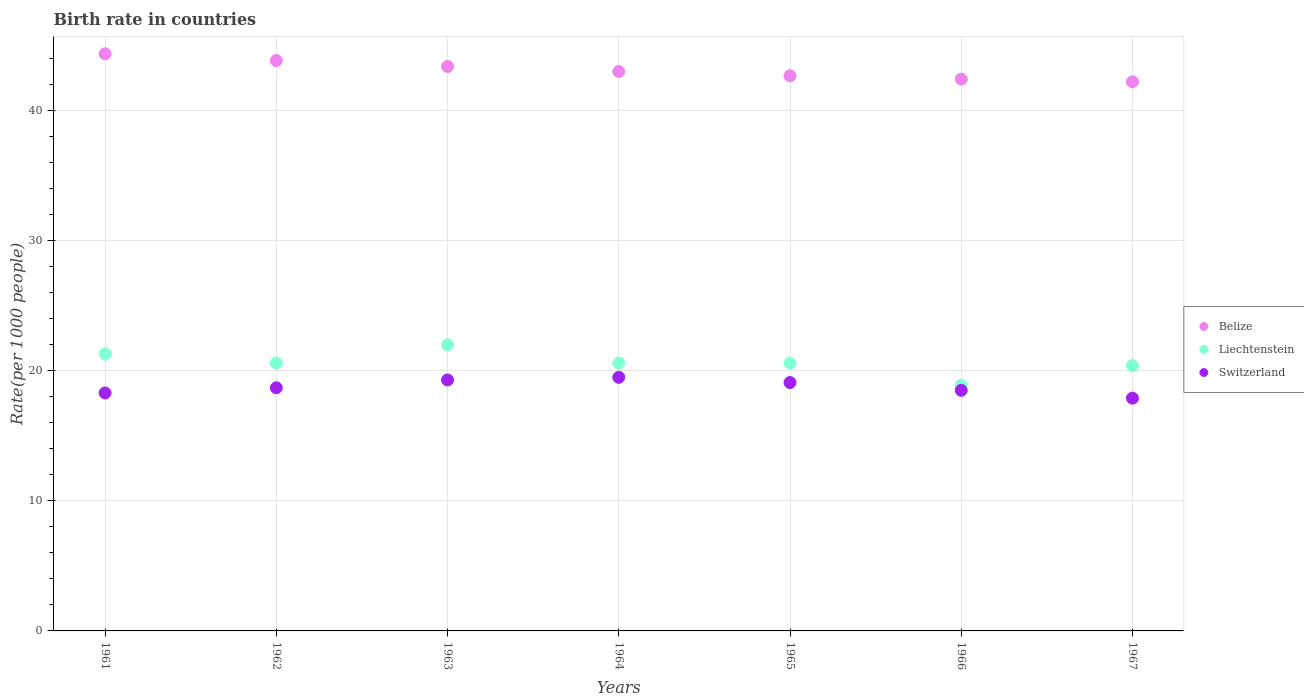Is the number of dotlines equal to the number of legend labels?
Give a very brief answer. Yes. Across all years, what is the maximum birth rate in Switzerland?
Keep it short and to the point. 19.5. Across all years, what is the minimum birth rate in Belize?
Provide a short and direct response. 42.23. In which year was the birth rate in Switzerland maximum?
Offer a terse response. 1964. In which year was the birth rate in Liechtenstein minimum?
Ensure brevity in your answer.  1966. What is the total birth rate in Liechtenstein in the graph?
Your response must be concise. 144.4. What is the difference between the birth rate in Switzerland in 1966 and that in 1967?
Offer a very short reply. 0.6. What is the difference between the birth rate in Belize in 1961 and the birth rate in Switzerland in 1963?
Make the answer very short. 25.08. What is the average birth rate in Switzerland per year?
Your response must be concise. 18.76. In the year 1965, what is the difference between the birth rate in Switzerland and birth rate in Belize?
Your answer should be compact. -23.59. In how many years, is the birth rate in Belize greater than 34?
Your response must be concise. 7. What is the ratio of the birth rate in Liechtenstein in 1963 to that in 1964?
Give a very brief answer. 1.07. Is the difference between the birth rate in Switzerland in 1962 and 1963 greater than the difference between the birth rate in Belize in 1962 and 1963?
Make the answer very short. No. What is the difference between the highest and the second highest birth rate in Liechtenstein?
Your response must be concise. 0.7. What is the difference between the highest and the lowest birth rate in Liechtenstein?
Offer a terse response. 3.1. Is it the case that in every year, the sum of the birth rate in Belize and birth rate in Switzerland  is greater than the birth rate in Liechtenstein?
Your answer should be compact. Yes. Is the birth rate in Liechtenstein strictly less than the birth rate in Switzerland over the years?
Keep it short and to the point. No. How are the legend labels stacked?
Ensure brevity in your answer.  Vertical. What is the title of the graph?
Your answer should be very brief. Birth rate in countries. Does "Greece" appear as one of the legend labels in the graph?
Your response must be concise. No. What is the label or title of the Y-axis?
Give a very brief answer. Rate(per 1000 people). What is the Rate(per 1000 people) in Belize in 1961?
Ensure brevity in your answer.  44.38. What is the Rate(per 1000 people) of Liechtenstein in 1961?
Your answer should be very brief. 21.3. What is the Rate(per 1000 people) in Belize in 1962?
Ensure brevity in your answer.  43.86. What is the Rate(per 1000 people) of Liechtenstein in 1962?
Provide a short and direct response. 20.6. What is the Rate(per 1000 people) in Belize in 1963?
Your answer should be very brief. 43.41. What is the Rate(per 1000 people) in Switzerland in 1963?
Offer a terse response. 19.3. What is the Rate(per 1000 people) in Belize in 1964?
Your answer should be compact. 43.02. What is the Rate(per 1000 people) of Liechtenstein in 1964?
Offer a very short reply. 20.6. What is the Rate(per 1000 people) of Belize in 1965?
Your answer should be compact. 42.69. What is the Rate(per 1000 people) of Liechtenstein in 1965?
Provide a short and direct response. 20.6. What is the Rate(per 1000 people) in Belize in 1966?
Provide a short and direct response. 42.43. What is the Rate(per 1000 people) of Liechtenstein in 1966?
Keep it short and to the point. 18.9. What is the Rate(per 1000 people) in Belize in 1967?
Your response must be concise. 42.23. What is the Rate(per 1000 people) of Liechtenstein in 1967?
Offer a terse response. 20.4. What is the Rate(per 1000 people) in Switzerland in 1967?
Keep it short and to the point. 17.9. Across all years, what is the maximum Rate(per 1000 people) of Belize?
Offer a terse response. 44.38. Across all years, what is the minimum Rate(per 1000 people) in Belize?
Give a very brief answer. 42.23. Across all years, what is the minimum Rate(per 1000 people) in Liechtenstein?
Ensure brevity in your answer.  18.9. Across all years, what is the minimum Rate(per 1000 people) of Switzerland?
Make the answer very short. 17.9. What is the total Rate(per 1000 people) in Belize in the graph?
Your answer should be compact. 302.02. What is the total Rate(per 1000 people) in Liechtenstein in the graph?
Your answer should be compact. 144.4. What is the total Rate(per 1000 people) in Switzerland in the graph?
Your answer should be very brief. 131.3. What is the difference between the Rate(per 1000 people) of Belize in 1961 and that in 1962?
Give a very brief answer. 0.52. What is the difference between the Rate(per 1000 people) of Liechtenstein in 1961 and that in 1962?
Your answer should be compact. 0.7. What is the difference between the Rate(per 1000 people) of Switzerland in 1961 and that in 1962?
Your answer should be very brief. -0.4. What is the difference between the Rate(per 1000 people) in Switzerland in 1961 and that in 1963?
Offer a terse response. -1. What is the difference between the Rate(per 1000 people) of Belize in 1961 and that in 1964?
Your answer should be very brief. 1.36. What is the difference between the Rate(per 1000 people) in Belize in 1961 and that in 1965?
Offer a terse response. 1.69. What is the difference between the Rate(per 1000 people) of Liechtenstein in 1961 and that in 1965?
Offer a terse response. 0.7. What is the difference between the Rate(per 1000 people) of Belize in 1961 and that in 1966?
Your answer should be very brief. 1.95. What is the difference between the Rate(per 1000 people) in Switzerland in 1961 and that in 1966?
Give a very brief answer. -0.2. What is the difference between the Rate(per 1000 people) in Belize in 1961 and that in 1967?
Give a very brief answer. 2.15. What is the difference between the Rate(per 1000 people) of Liechtenstein in 1961 and that in 1967?
Your answer should be compact. 0.9. What is the difference between the Rate(per 1000 people) in Switzerland in 1961 and that in 1967?
Offer a very short reply. 0.4. What is the difference between the Rate(per 1000 people) of Belize in 1962 and that in 1963?
Provide a succinct answer. 0.46. What is the difference between the Rate(per 1000 people) of Liechtenstein in 1962 and that in 1963?
Your answer should be compact. -1.4. What is the difference between the Rate(per 1000 people) in Belize in 1962 and that in 1964?
Your answer should be very brief. 0.84. What is the difference between the Rate(per 1000 people) in Liechtenstein in 1962 and that in 1964?
Give a very brief answer. 0. What is the difference between the Rate(per 1000 people) of Belize in 1962 and that in 1965?
Provide a succinct answer. 1.17. What is the difference between the Rate(per 1000 people) in Liechtenstein in 1962 and that in 1965?
Offer a very short reply. 0. What is the difference between the Rate(per 1000 people) in Belize in 1962 and that in 1966?
Make the answer very short. 1.43. What is the difference between the Rate(per 1000 people) of Switzerland in 1962 and that in 1966?
Make the answer very short. 0.2. What is the difference between the Rate(per 1000 people) in Belize in 1962 and that in 1967?
Give a very brief answer. 1.63. What is the difference between the Rate(per 1000 people) of Liechtenstein in 1962 and that in 1967?
Provide a succinct answer. 0.2. What is the difference between the Rate(per 1000 people) of Switzerland in 1962 and that in 1967?
Ensure brevity in your answer.  0.8. What is the difference between the Rate(per 1000 people) of Belize in 1963 and that in 1964?
Offer a very short reply. 0.39. What is the difference between the Rate(per 1000 people) in Belize in 1963 and that in 1965?
Ensure brevity in your answer.  0.71. What is the difference between the Rate(per 1000 people) of Liechtenstein in 1963 and that in 1965?
Your answer should be compact. 1.4. What is the difference between the Rate(per 1000 people) of Liechtenstein in 1963 and that in 1966?
Offer a very short reply. 3.1. What is the difference between the Rate(per 1000 people) of Switzerland in 1963 and that in 1966?
Your answer should be very brief. 0.8. What is the difference between the Rate(per 1000 people) of Belize in 1963 and that in 1967?
Offer a very short reply. 1.18. What is the difference between the Rate(per 1000 people) of Liechtenstein in 1963 and that in 1967?
Ensure brevity in your answer.  1.6. What is the difference between the Rate(per 1000 people) of Switzerland in 1963 and that in 1967?
Offer a terse response. 1.4. What is the difference between the Rate(per 1000 people) in Belize in 1964 and that in 1965?
Make the answer very short. 0.33. What is the difference between the Rate(per 1000 people) of Belize in 1964 and that in 1966?
Make the answer very short. 0.59. What is the difference between the Rate(per 1000 people) of Liechtenstein in 1964 and that in 1966?
Your answer should be very brief. 1.7. What is the difference between the Rate(per 1000 people) of Switzerland in 1964 and that in 1966?
Your response must be concise. 1. What is the difference between the Rate(per 1000 people) of Belize in 1964 and that in 1967?
Offer a terse response. 0.79. What is the difference between the Rate(per 1000 people) in Belize in 1965 and that in 1966?
Your response must be concise. 0.26. What is the difference between the Rate(per 1000 people) of Belize in 1965 and that in 1967?
Your response must be concise. 0.46. What is the difference between the Rate(per 1000 people) in Belize in 1966 and that in 1967?
Your answer should be very brief. 0.2. What is the difference between the Rate(per 1000 people) in Belize in 1961 and the Rate(per 1000 people) in Liechtenstein in 1962?
Your response must be concise. 23.78. What is the difference between the Rate(per 1000 people) in Belize in 1961 and the Rate(per 1000 people) in Switzerland in 1962?
Make the answer very short. 25.68. What is the difference between the Rate(per 1000 people) in Liechtenstein in 1961 and the Rate(per 1000 people) in Switzerland in 1962?
Make the answer very short. 2.6. What is the difference between the Rate(per 1000 people) of Belize in 1961 and the Rate(per 1000 people) of Liechtenstein in 1963?
Keep it short and to the point. 22.38. What is the difference between the Rate(per 1000 people) of Belize in 1961 and the Rate(per 1000 people) of Switzerland in 1963?
Keep it short and to the point. 25.08. What is the difference between the Rate(per 1000 people) of Liechtenstein in 1961 and the Rate(per 1000 people) of Switzerland in 1963?
Provide a succinct answer. 2. What is the difference between the Rate(per 1000 people) in Belize in 1961 and the Rate(per 1000 people) in Liechtenstein in 1964?
Provide a succinct answer. 23.78. What is the difference between the Rate(per 1000 people) in Belize in 1961 and the Rate(per 1000 people) in Switzerland in 1964?
Give a very brief answer. 24.88. What is the difference between the Rate(per 1000 people) of Liechtenstein in 1961 and the Rate(per 1000 people) of Switzerland in 1964?
Ensure brevity in your answer.  1.8. What is the difference between the Rate(per 1000 people) in Belize in 1961 and the Rate(per 1000 people) in Liechtenstein in 1965?
Make the answer very short. 23.78. What is the difference between the Rate(per 1000 people) in Belize in 1961 and the Rate(per 1000 people) in Switzerland in 1965?
Your answer should be compact. 25.28. What is the difference between the Rate(per 1000 people) of Belize in 1961 and the Rate(per 1000 people) of Liechtenstein in 1966?
Offer a very short reply. 25.48. What is the difference between the Rate(per 1000 people) of Belize in 1961 and the Rate(per 1000 people) of Switzerland in 1966?
Your response must be concise. 25.88. What is the difference between the Rate(per 1000 people) in Belize in 1961 and the Rate(per 1000 people) in Liechtenstein in 1967?
Make the answer very short. 23.98. What is the difference between the Rate(per 1000 people) of Belize in 1961 and the Rate(per 1000 people) of Switzerland in 1967?
Provide a succinct answer. 26.48. What is the difference between the Rate(per 1000 people) of Belize in 1962 and the Rate(per 1000 people) of Liechtenstein in 1963?
Provide a succinct answer. 21.86. What is the difference between the Rate(per 1000 people) of Belize in 1962 and the Rate(per 1000 people) of Switzerland in 1963?
Provide a short and direct response. 24.56. What is the difference between the Rate(per 1000 people) of Belize in 1962 and the Rate(per 1000 people) of Liechtenstein in 1964?
Provide a succinct answer. 23.26. What is the difference between the Rate(per 1000 people) in Belize in 1962 and the Rate(per 1000 people) in Switzerland in 1964?
Offer a terse response. 24.36. What is the difference between the Rate(per 1000 people) in Belize in 1962 and the Rate(per 1000 people) in Liechtenstein in 1965?
Ensure brevity in your answer.  23.26. What is the difference between the Rate(per 1000 people) of Belize in 1962 and the Rate(per 1000 people) of Switzerland in 1965?
Provide a short and direct response. 24.76. What is the difference between the Rate(per 1000 people) of Liechtenstein in 1962 and the Rate(per 1000 people) of Switzerland in 1965?
Offer a terse response. 1.5. What is the difference between the Rate(per 1000 people) in Belize in 1962 and the Rate(per 1000 people) in Liechtenstein in 1966?
Your response must be concise. 24.96. What is the difference between the Rate(per 1000 people) in Belize in 1962 and the Rate(per 1000 people) in Switzerland in 1966?
Your response must be concise. 25.36. What is the difference between the Rate(per 1000 people) of Liechtenstein in 1962 and the Rate(per 1000 people) of Switzerland in 1966?
Ensure brevity in your answer.  2.1. What is the difference between the Rate(per 1000 people) of Belize in 1962 and the Rate(per 1000 people) of Liechtenstein in 1967?
Provide a short and direct response. 23.46. What is the difference between the Rate(per 1000 people) of Belize in 1962 and the Rate(per 1000 people) of Switzerland in 1967?
Offer a terse response. 25.96. What is the difference between the Rate(per 1000 people) of Liechtenstein in 1962 and the Rate(per 1000 people) of Switzerland in 1967?
Offer a very short reply. 2.7. What is the difference between the Rate(per 1000 people) in Belize in 1963 and the Rate(per 1000 people) in Liechtenstein in 1964?
Give a very brief answer. 22.81. What is the difference between the Rate(per 1000 people) in Belize in 1963 and the Rate(per 1000 people) in Switzerland in 1964?
Your answer should be compact. 23.91. What is the difference between the Rate(per 1000 people) in Belize in 1963 and the Rate(per 1000 people) in Liechtenstein in 1965?
Your answer should be compact. 22.81. What is the difference between the Rate(per 1000 people) in Belize in 1963 and the Rate(per 1000 people) in Switzerland in 1965?
Offer a terse response. 24.31. What is the difference between the Rate(per 1000 people) in Liechtenstein in 1963 and the Rate(per 1000 people) in Switzerland in 1965?
Give a very brief answer. 2.9. What is the difference between the Rate(per 1000 people) in Belize in 1963 and the Rate(per 1000 people) in Liechtenstein in 1966?
Make the answer very short. 24.51. What is the difference between the Rate(per 1000 people) in Belize in 1963 and the Rate(per 1000 people) in Switzerland in 1966?
Keep it short and to the point. 24.91. What is the difference between the Rate(per 1000 people) in Belize in 1963 and the Rate(per 1000 people) in Liechtenstein in 1967?
Keep it short and to the point. 23.01. What is the difference between the Rate(per 1000 people) in Belize in 1963 and the Rate(per 1000 people) in Switzerland in 1967?
Provide a short and direct response. 25.51. What is the difference between the Rate(per 1000 people) in Liechtenstein in 1963 and the Rate(per 1000 people) in Switzerland in 1967?
Keep it short and to the point. 4.1. What is the difference between the Rate(per 1000 people) of Belize in 1964 and the Rate(per 1000 people) of Liechtenstein in 1965?
Provide a short and direct response. 22.42. What is the difference between the Rate(per 1000 people) in Belize in 1964 and the Rate(per 1000 people) in Switzerland in 1965?
Your response must be concise. 23.92. What is the difference between the Rate(per 1000 people) in Liechtenstein in 1964 and the Rate(per 1000 people) in Switzerland in 1965?
Offer a terse response. 1.5. What is the difference between the Rate(per 1000 people) in Belize in 1964 and the Rate(per 1000 people) in Liechtenstein in 1966?
Offer a very short reply. 24.12. What is the difference between the Rate(per 1000 people) of Belize in 1964 and the Rate(per 1000 people) of Switzerland in 1966?
Keep it short and to the point. 24.52. What is the difference between the Rate(per 1000 people) in Belize in 1964 and the Rate(per 1000 people) in Liechtenstein in 1967?
Keep it short and to the point. 22.62. What is the difference between the Rate(per 1000 people) of Belize in 1964 and the Rate(per 1000 people) of Switzerland in 1967?
Ensure brevity in your answer.  25.12. What is the difference between the Rate(per 1000 people) of Liechtenstein in 1964 and the Rate(per 1000 people) of Switzerland in 1967?
Offer a very short reply. 2.7. What is the difference between the Rate(per 1000 people) of Belize in 1965 and the Rate(per 1000 people) of Liechtenstein in 1966?
Give a very brief answer. 23.79. What is the difference between the Rate(per 1000 people) of Belize in 1965 and the Rate(per 1000 people) of Switzerland in 1966?
Your answer should be compact. 24.19. What is the difference between the Rate(per 1000 people) of Belize in 1965 and the Rate(per 1000 people) of Liechtenstein in 1967?
Give a very brief answer. 22.29. What is the difference between the Rate(per 1000 people) in Belize in 1965 and the Rate(per 1000 people) in Switzerland in 1967?
Offer a terse response. 24.79. What is the difference between the Rate(per 1000 people) in Liechtenstein in 1965 and the Rate(per 1000 people) in Switzerland in 1967?
Give a very brief answer. 2.7. What is the difference between the Rate(per 1000 people) of Belize in 1966 and the Rate(per 1000 people) of Liechtenstein in 1967?
Your answer should be very brief. 22.03. What is the difference between the Rate(per 1000 people) in Belize in 1966 and the Rate(per 1000 people) in Switzerland in 1967?
Keep it short and to the point. 24.53. What is the difference between the Rate(per 1000 people) in Liechtenstein in 1966 and the Rate(per 1000 people) in Switzerland in 1967?
Give a very brief answer. 1. What is the average Rate(per 1000 people) in Belize per year?
Ensure brevity in your answer.  43.15. What is the average Rate(per 1000 people) in Liechtenstein per year?
Make the answer very short. 20.63. What is the average Rate(per 1000 people) of Switzerland per year?
Give a very brief answer. 18.76. In the year 1961, what is the difference between the Rate(per 1000 people) in Belize and Rate(per 1000 people) in Liechtenstein?
Provide a short and direct response. 23.08. In the year 1961, what is the difference between the Rate(per 1000 people) of Belize and Rate(per 1000 people) of Switzerland?
Give a very brief answer. 26.08. In the year 1961, what is the difference between the Rate(per 1000 people) in Liechtenstein and Rate(per 1000 people) in Switzerland?
Provide a short and direct response. 3. In the year 1962, what is the difference between the Rate(per 1000 people) of Belize and Rate(per 1000 people) of Liechtenstein?
Offer a very short reply. 23.26. In the year 1962, what is the difference between the Rate(per 1000 people) of Belize and Rate(per 1000 people) of Switzerland?
Keep it short and to the point. 25.16. In the year 1962, what is the difference between the Rate(per 1000 people) of Liechtenstein and Rate(per 1000 people) of Switzerland?
Provide a short and direct response. 1.9. In the year 1963, what is the difference between the Rate(per 1000 people) in Belize and Rate(per 1000 people) in Liechtenstein?
Keep it short and to the point. 21.41. In the year 1963, what is the difference between the Rate(per 1000 people) in Belize and Rate(per 1000 people) in Switzerland?
Provide a short and direct response. 24.11. In the year 1964, what is the difference between the Rate(per 1000 people) of Belize and Rate(per 1000 people) of Liechtenstein?
Provide a short and direct response. 22.42. In the year 1964, what is the difference between the Rate(per 1000 people) in Belize and Rate(per 1000 people) in Switzerland?
Keep it short and to the point. 23.52. In the year 1964, what is the difference between the Rate(per 1000 people) of Liechtenstein and Rate(per 1000 people) of Switzerland?
Make the answer very short. 1.1. In the year 1965, what is the difference between the Rate(per 1000 people) in Belize and Rate(per 1000 people) in Liechtenstein?
Provide a short and direct response. 22.09. In the year 1965, what is the difference between the Rate(per 1000 people) in Belize and Rate(per 1000 people) in Switzerland?
Offer a terse response. 23.59. In the year 1965, what is the difference between the Rate(per 1000 people) of Liechtenstein and Rate(per 1000 people) of Switzerland?
Offer a very short reply. 1.5. In the year 1966, what is the difference between the Rate(per 1000 people) in Belize and Rate(per 1000 people) in Liechtenstein?
Ensure brevity in your answer.  23.53. In the year 1966, what is the difference between the Rate(per 1000 people) in Belize and Rate(per 1000 people) in Switzerland?
Provide a succinct answer. 23.93. In the year 1966, what is the difference between the Rate(per 1000 people) in Liechtenstein and Rate(per 1000 people) in Switzerland?
Make the answer very short. 0.4. In the year 1967, what is the difference between the Rate(per 1000 people) of Belize and Rate(per 1000 people) of Liechtenstein?
Provide a succinct answer. 21.83. In the year 1967, what is the difference between the Rate(per 1000 people) in Belize and Rate(per 1000 people) in Switzerland?
Provide a short and direct response. 24.33. What is the ratio of the Rate(per 1000 people) in Belize in 1961 to that in 1962?
Ensure brevity in your answer.  1.01. What is the ratio of the Rate(per 1000 people) of Liechtenstein in 1961 to that in 1962?
Keep it short and to the point. 1.03. What is the ratio of the Rate(per 1000 people) of Switzerland in 1961 to that in 1962?
Provide a succinct answer. 0.98. What is the ratio of the Rate(per 1000 people) of Belize in 1961 to that in 1963?
Provide a succinct answer. 1.02. What is the ratio of the Rate(per 1000 people) in Liechtenstein in 1961 to that in 1963?
Give a very brief answer. 0.97. What is the ratio of the Rate(per 1000 people) of Switzerland in 1961 to that in 1963?
Ensure brevity in your answer.  0.95. What is the ratio of the Rate(per 1000 people) in Belize in 1961 to that in 1964?
Offer a very short reply. 1.03. What is the ratio of the Rate(per 1000 people) in Liechtenstein in 1961 to that in 1964?
Your answer should be compact. 1.03. What is the ratio of the Rate(per 1000 people) in Switzerland in 1961 to that in 1964?
Keep it short and to the point. 0.94. What is the ratio of the Rate(per 1000 people) in Belize in 1961 to that in 1965?
Ensure brevity in your answer.  1.04. What is the ratio of the Rate(per 1000 people) in Liechtenstein in 1961 to that in 1965?
Your response must be concise. 1.03. What is the ratio of the Rate(per 1000 people) in Switzerland in 1961 to that in 1965?
Make the answer very short. 0.96. What is the ratio of the Rate(per 1000 people) in Belize in 1961 to that in 1966?
Keep it short and to the point. 1.05. What is the ratio of the Rate(per 1000 people) in Liechtenstein in 1961 to that in 1966?
Offer a very short reply. 1.13. What is the ratio of the Rate(per 1000 people) of Belize in 1961 to that in 1967?
Offer a very short reply. 1.05. What is the ratio of the Rate(per 1000 people) of Liechtenstein in 1961 to that in 1967?
Give a very brief answer. 1.04. What is the ratio of the Rate(per 1000 people) of Switzerland in 1961 to that in 1967?
Your answer should be compact. 1.02. What is the ratio of the Rate(per 1000 people) of Belize in 1962 to that in 1963?
Your answer should be very brief. 1.01. What is the ratio of the Rate(per 1000 people) in Liechtenstein in 1962 to that in 1963?
Your response must be concise. 0.94. What is the ratio of the Rate(per 1000 people) of Switzerland in 1962 to that in 1963?
Your answer should be very brief. 0.97. What is the ratio of the Rate(per 1000 people) of Belize in 1962 to that in 1964?
Provide a succinct answer. 1.02. What is the ratio of the Rate(per 1000 people) in Liechtenstein in 1962 to that in 1964?
Offer a very short reply. 1. What is the ratio of the Rate(per 1000 people) of Belize in 1962 to that in 1965?
Offer a very short reply. 1.03. What is the ratio of the Rate(per 1000 people) of Switzerland in 1962 to that in 1965?
Offer a very short reply. 0.98. What is the ratio of the Rate(per 1000 people) of Belize in 1962 to that in 1966?
Make the answer very short. 1.03. What is the ratio of the Rate(per 1000 people) in Liechtenstein in 1962 to that in 1966?
Ensure brevity in your answer.  1.09. What is the ratio of the Rate(per 1000 people) of Switzerland in 1962 to that in 1966?
Provide a short and direct response. 1.01. What is the ratio of the Rate(per 1000 people) of Belize in 1962 to that in 1967?
Make the answer very short. 1.04. What is the ratio of the Rate(per 1000 people) in Liechtenstein in 1962 to that in 1967?
Your response must be concise. 1.01. What is the ratio of the Rate(per 1000 people) in Switzerland in 1962 to that in 1967?
Make the answer very short. 1.04. What is the ratio of the Rate(per 1000 people) in Liechtenstein in 1963 to that in 1964?
Make the answer very short. 1.07. What is the ratio of the Rate(per 1000 people) of Belize in 1963 to that in 1965?
Your answer should be very brief. 1.02. What is the ratio of the Rate(per 1000 people) of Liechtenstein in 1963 to that in 1965?
Give a very brief answer. 1.07. What is the ratio of the Rate(per 1000 people) in Switzerland in 1963 to that in 1965?
Offer a terse response. 1.01. What is the ratio of the Rate(per 1000 people) of Belize in 1963 to that in 1966?
Keep it short and to the point. 1.02. What is the ratio of the Rate(per 1000 people) in Liechtenstein in 1963 to that in 1966?
Your answer should be compact. 1.16. What is the ratio of the Rate(per 1000 people) of Switzerland in 1963 to that in 1966?
Make the answer very short. 1.04. What is the ratio of the Rate(per 1000 people) of Belize in 1963 to that in 1967?
Provide a succinct answer. 1.03. What is the ratio of the Rate(per 1000 people) of Liechtenstein in 1963 to that in 1967?
Your answer should be very brief. 1.08. What is the ratio of the Rate(per 1000 people) of Switzerland in 1963 to that in 1967?
Provide a succinct answer. 1.08. What is the ratio of the Rate(per 1000 people) in Belize in 1964 to that in 1965?
Keep it short and to the point. 1.01. What is the ratio of the Rate(per 1000 people) of Liechtenstein in 1964 to that in 1965?
Offer a terse response. 1. What is the ratio of the Rate(per 1000 people) in Switzerland in 1964 to that in 1965?
Offer a terse response. 1.02. What is the ratio of the Rate(per 1000 people) of Belize in 1964 to that in 1966?
Your answer should be very brief. 1.01. What is the ratio of the Rate(per 1000 people) in Liechtenstein in 1964 to that in 1966?
Your answer should be compact. 1.09. What is the ratio of the Rate(per 1000 people) of Switzerland in 1964 to that in 1966?
Provide a succinct answer. 1.05. What is the ratio of the Rate(per 1000 people) of Belize in 1964 to that in 1967?
Ensure brevity in your answer.  1.02. What is the ratio of the Rate(per 1000 people) of Liechtenstein in 1964 to that in 1967?
Provide a short and direct response. 1.01. What is the ratio of the Rate(per 1000 people) of Switzerland in 1964 to that in 1967?
Your response must be concise. 1.09. What is the ratio of the Rate(per 1000 people) of Belize in 1965 to that in 1966?
Offer a very short reply. 1.01. What is the ratio of the Rate(per 1000 people) in Liechtenstein in 1965 to that in 1966?
Give a very brief answer. 1.09. What is the ratio of the Rate(per 1000 people) of Switzerland in 1965 to that in 1966?
Your answer should be very brief. 1.03. What is the ratio of the Rate(per 1000 people) of Belize in 1965 to that in 1967?
Give a very brief answer. 1.01. What is the ratio of the Rate(per 1000 people) in Liechtenstein in 1965 to that in 1967?
Your answer should be compact. 1.01. What is the ratio of the Rate(per 1000 people) of Switzerland in 1965 to that in 1967?
Make the answer very short. 1.07. What is the ratio of the Rate(per 1000 people) of Belize in 1966 to that in 1967?
Your response must be concise. 1. What is the ratio of the Rate(per 1000 people) of Liechtenstein in 1966 to that in 1967?
Make the answer very short. 0.93. What is the ratio of the Rate(per 1000 people) of Switzerland in 1966 to that in 1967?
Provide a short and direct response. 1.03. What is the difference between the highest and the second highest Rate(per 1000 people) in Belize?
Keep it short and to the point. 0.52. What is the difference between the highest and the second highest Rate(per 1000 people) of Switzerland?
Give a very brief answer. 0.2. What is the difference between the highest and the lowest Rate(per 1000 people) in Belize?
Make the answer very short. 2.15. What is the difference between the highest and the lowest Rate(per 1000 people) of Liechtenstein?
Provide a succinct answer. 3.1. 